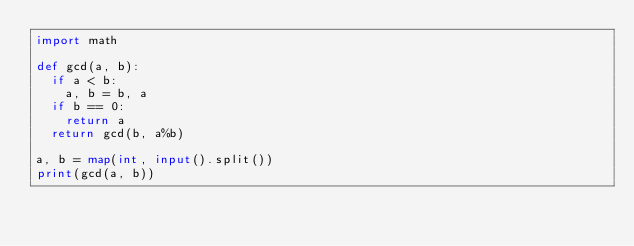Convert code to text. <code><loc_0><loc_0><loc_500><loc_500><_Python_>import math

def gcd(a, b):
  if a < b:
    a, b = b, a
  if b == 0:
    return a
  return gcd(b, a%b)

a, b = map(int, input().split())
print(gcd(a, b))
</code> 